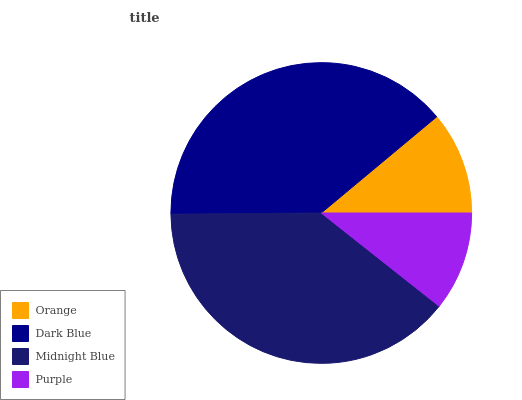Is Purple the minimum?
Answer yes or no. Yes. Is Midnight Blue the maximum?
Answer yes or no. Yes. Is Dark Blue the minimum?
Answer yes or no. No. Is Dark Blue the maximum?
Answer yes or no. No. Is Dark Blue greater than Orange?
Answer yes or no. Yes. Is Orange less than Dark Blue?
Answer yes or no. Yes. Is Orange greater than Dark Blue?
Answer yes or no. No. Is Dark Blue less than Orange?
Answer yes or no. No. Is Dark Blue the high median?
Answer yes or no. Yes. Is Orange the low median?
Answer yes or no. Yes. Is Orange the high median?
Answer yes or no. No. Is Purple the low median?
Answer yes or no. No. 